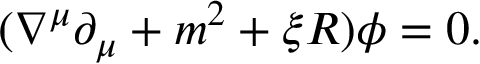Convert formula to latex. <formula><loc_0><loc_0><loc_500><loc_500>( \nabla ^ { \mu } \partial _ { \mu } + m ^ { 2 } + \xi R ) \phi = 0 .</formula> 